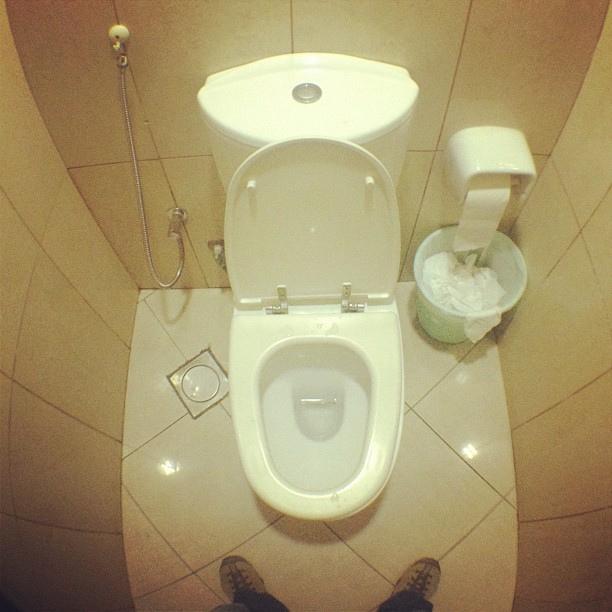What color is the bathroom walls?
Give a very brief answer. White. What is this room?
Quick response, please. Bathroom. How would you flush this toilet?
Concise answer only. Button. 